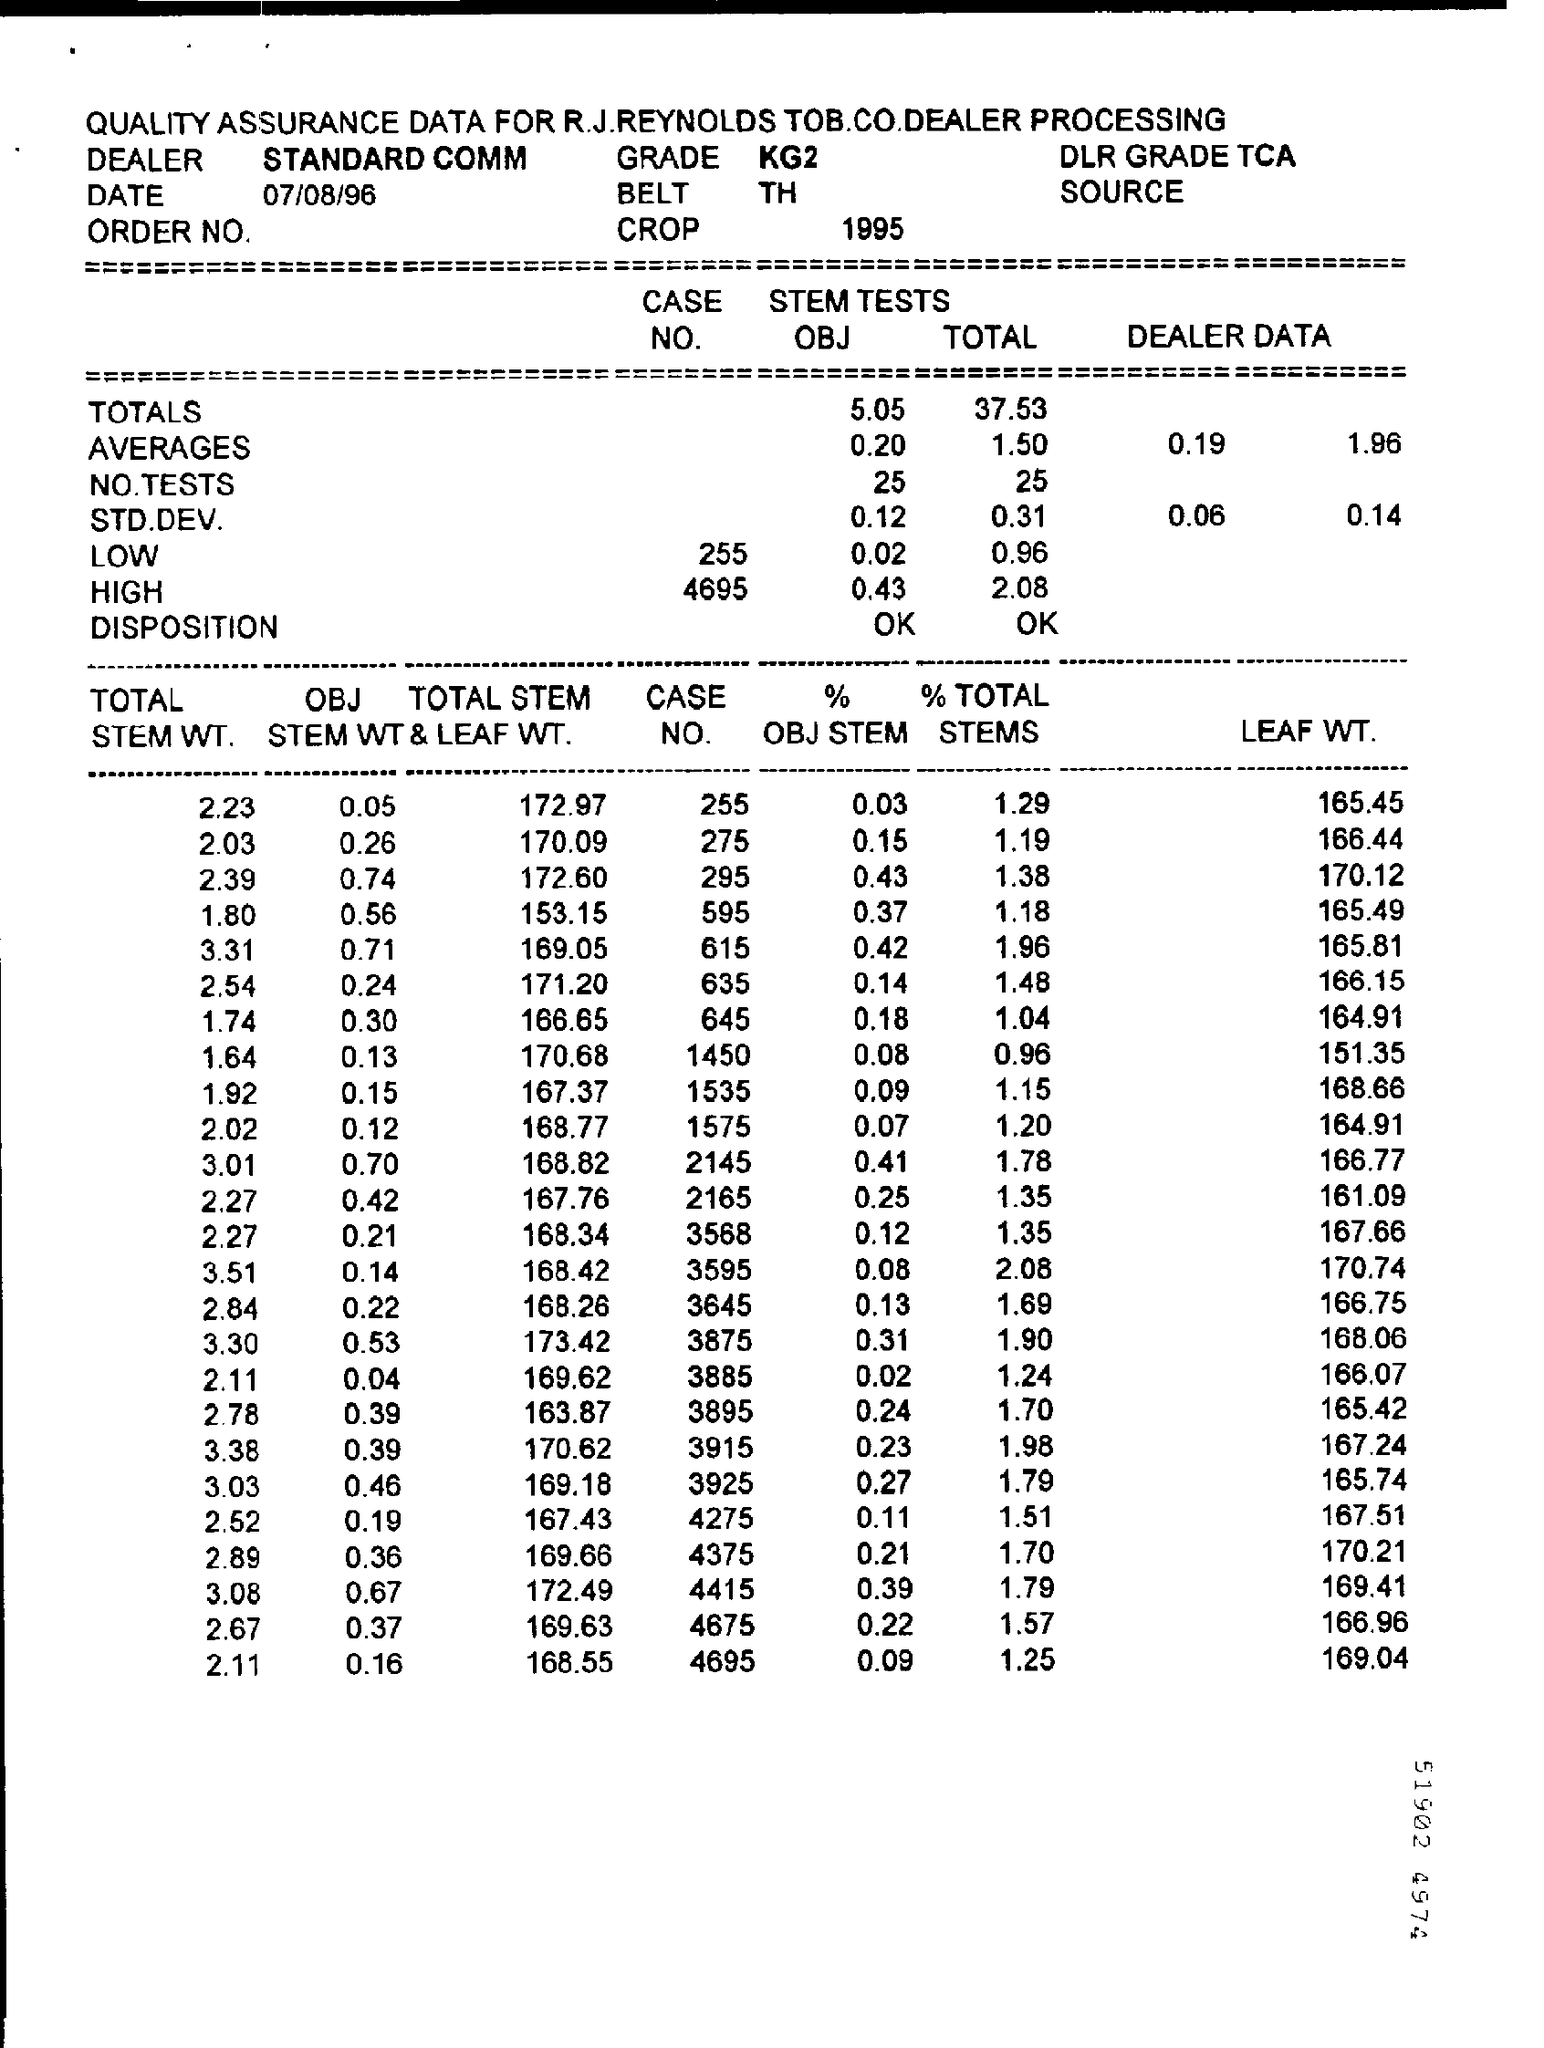Mention a couple of crucial points in this snapshot. The least leaf weight in the chart is 151.35. If the OBJ STEM WT is 0.21, then the total STEM & LEAF WT is 168.34. The calculated value of "LEAF WT" is 170.74, assuming that "TOTAL STEMS" is 2.08. If the total stem weight is 1.80, then the percentage of stem weight in the object is 0.37. What is the last CASE NO?" the person asked, "4695... 